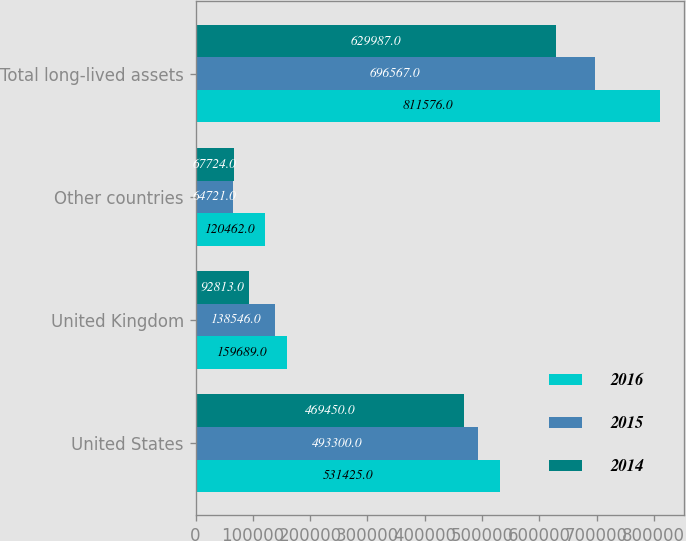Convert chart to OTSL. <chart><loc_0><loc_0><loc_500><loc_500><stacked_bar_chart><ecel><fcel>United States<fcel>United Kingdom<fcel>Other countries<fcel>Total long-lived assets<nl><fcel>2016<fcel>531425<fcel>159689<fcel>120462<fcel>811576<nl><fcel>2015<fcel>493300<fcel>138546<fcel>64721<fcel>696567<nl><fcel>2014<fcel>469450<fcel>92813<fcel>67724<fcel>629987<nl></chart> 